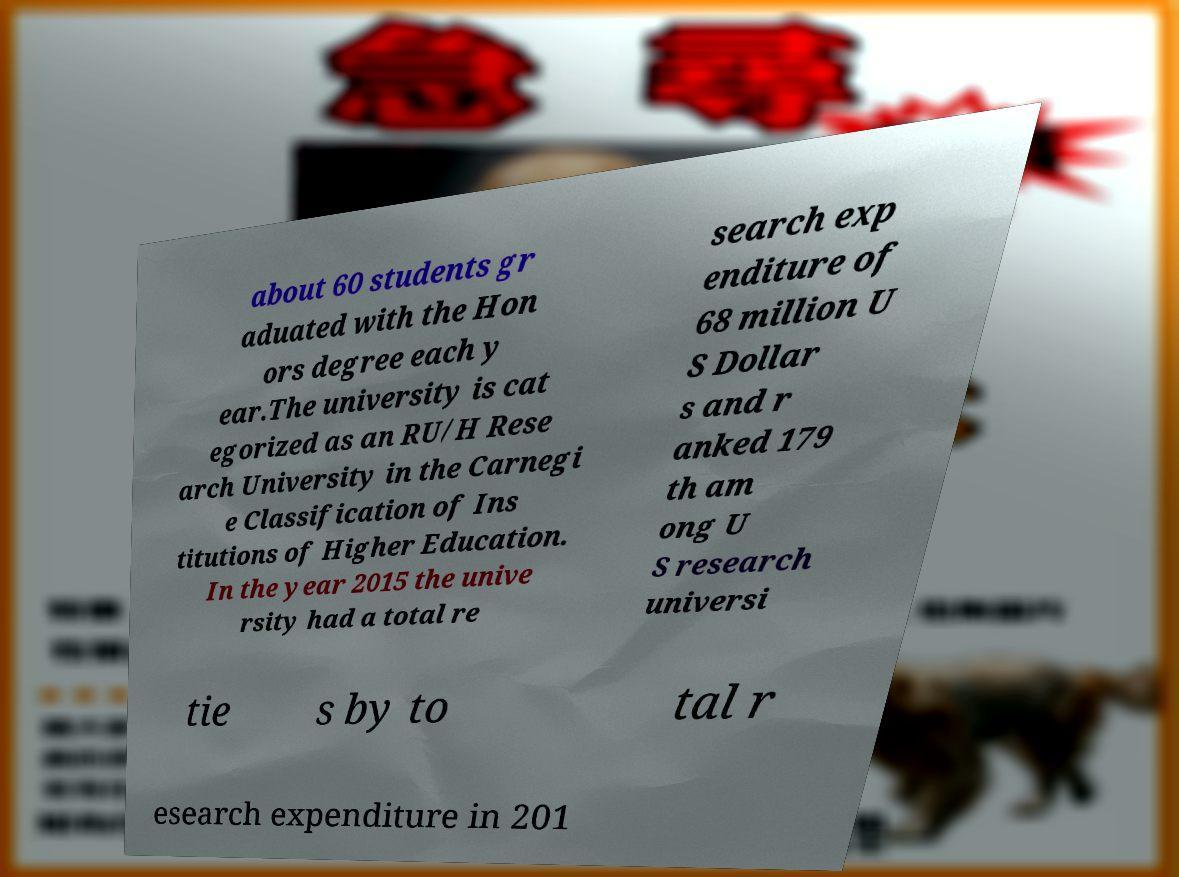Can you accurately transcribe the text from the provided image for me? about 60 students gr aduated with the Hon ors degree each y ear.The university is cat egorized as an RU/H Rese arch University in the Carnegi e Classification of Ins titutions of Higher Education. In the year 2015 the unive rsity had a total re search exp enditure of 68 million U S Dollar s and r anked 179 th am ong U S research universi tie s by to tal r esearch expenditure in 201 